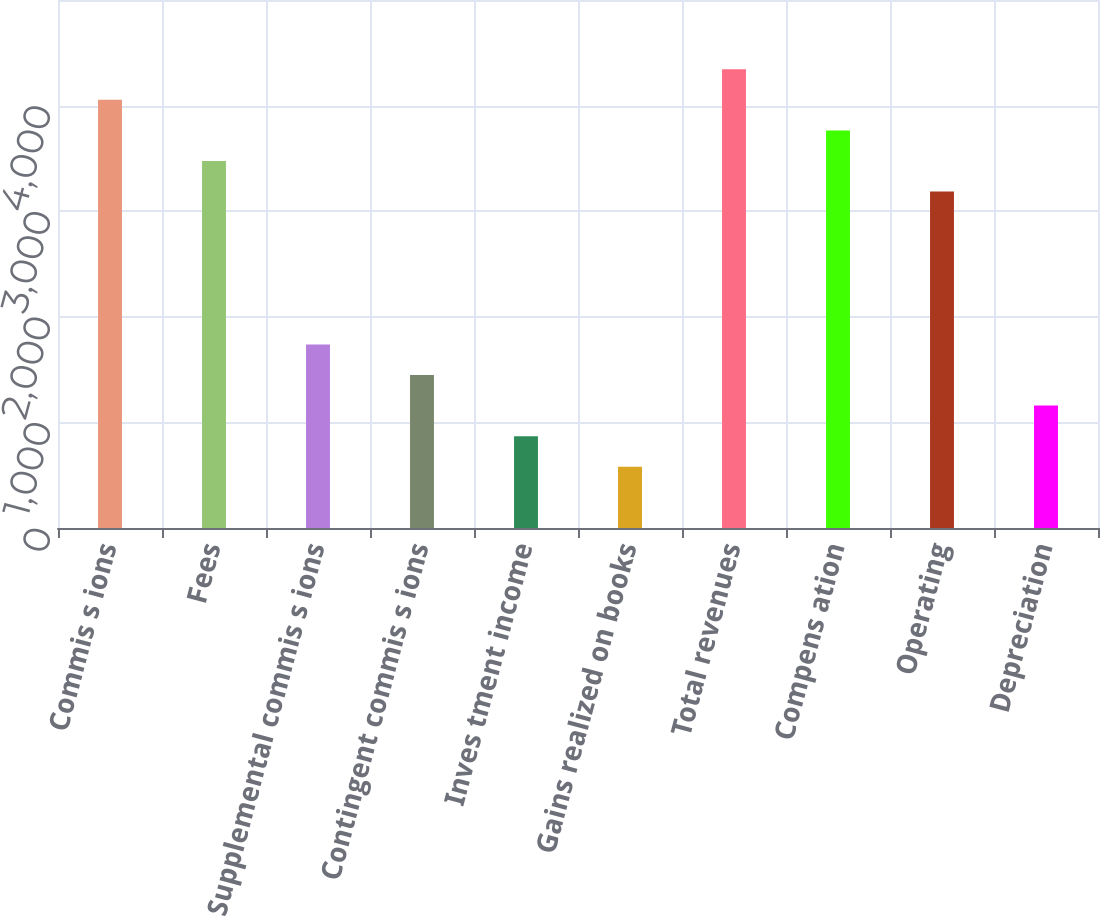Convert chart. <chart><loc_0><loc_0><loc_500><loc_500><bar_chart><fcel>Commis s ions<fcel>Fees<fcel>Supplemental commis s ions<fcel>Contingent commis s ions<fcel>Inves tment income<fcel>Gains realized on books<fcel>Total revenues<fcel>Compens ation<fcel>Operating<fcel>Depreciation<nl><fcel>4054.46<fcel>3475.38<fcel>1738.14<fcel>1448.6<fcel>869.52<fcel>579.98<fcel>4344<fcel>3764.92<fcel>3185.84<fcel>1159.06<nl></chart> 